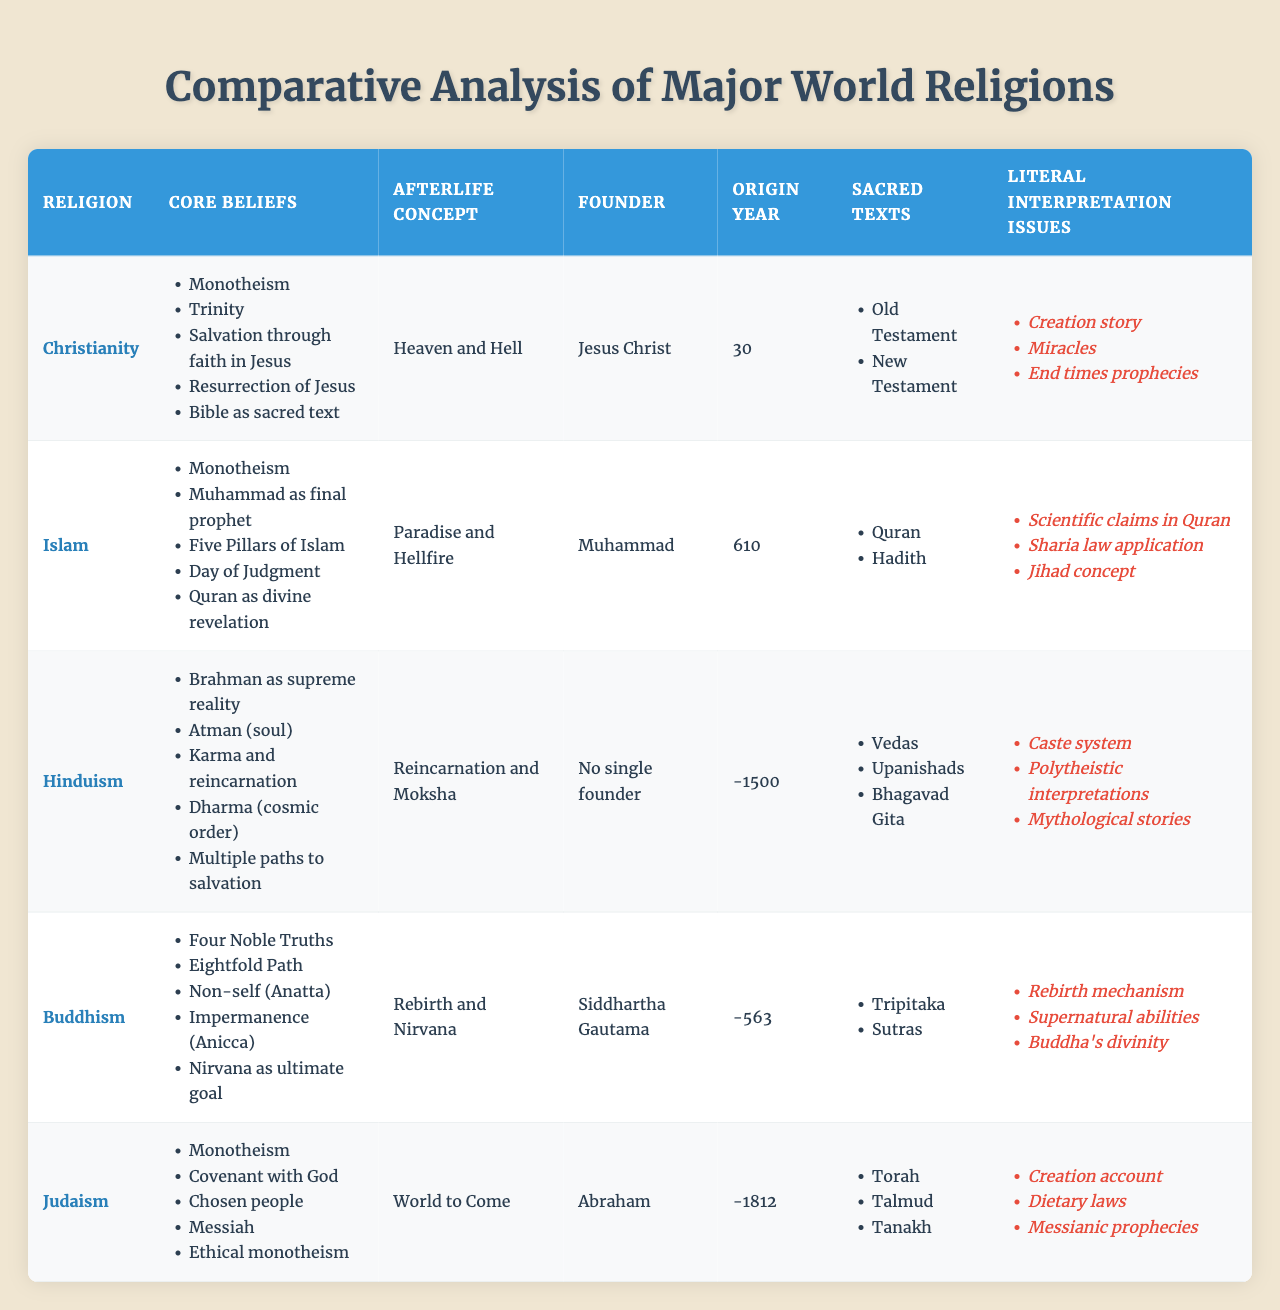What is the main afterlife concept in Buddhism? The afterlife concept for Buddhism, as listed in the table, is "Rebirth and Nirvana"
Answer: Rebirth and Nirvana Which religion emphasizes the concept of a "Covenant with God"? The table indicates that Judaism emphasizes the concept of a "Covenant with God" as one of its core beliefs
Answer: Judaism How many core beliefs does Islam have? By counting the listed core beliefs in the table, Islam has five core beliefs identified
Answer: 5 Which religion does not have a single founder? The table clearly states that Hinduism does not have a single founder, indicating the tradition's diverse origins
Answer: Hinduism Are the sacred texts of Christianity different from those of Islam? Comparing the sacred texts in the table, Christianity's texts (Old Testament, New Testament) differ from Islam's texts (Quran, Hadith)
Answer: Yes What is the origin year for Hinduism? The table shows that Hinduism has an origin year marked as -1500, indicating its ancient roots
Answer: -1500 Which religion's core beliefs include "Four Noble Truths" and "Eightfold Path"? According to the table, these core beliefs are part of Buddhism's foundational principles
Answer: Buddhism How many religions listed have Monotheism as a core belief? The table shows that Christianity, Islam, and Judaism each have Monotheism listed as a core belief, making a total of three religions
Answer: 3 Is the idea of the Trinity a core belief in Islam? The table specifies that the Trinity is a core belief in Christianity, not in Islam, thus the answer is no
Answer: No Which religion has issues related to the interpretation of dietary laws? The table illustrates that Judaism has literal interpretation issues related to dietary laws
Answer: Judaism Which two religions have "Resurrection" as a belief or concept associated with them? The table shows that Christianity includes the "Resurrection of Jesus", while Buddhism does not, indicating that only Christianity is relevant
Answer: Christianity 